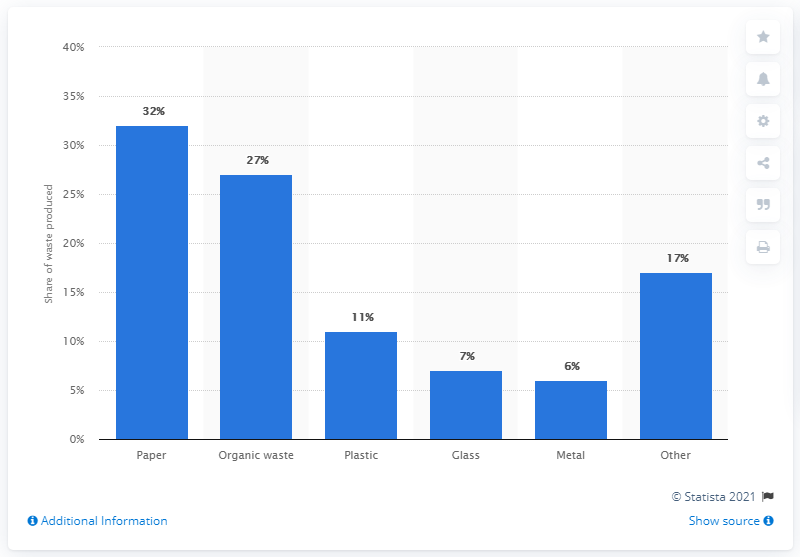Draw attention to some important aspects in this diagram. By 2025, it is forecasted that plastic will constitute approximately 11% of the municipal waste generated in OECD countries, according to estimates. 